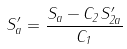<formula> <loc_0><loc_0><loc_500><loc_500>S _ { a } ^ { \prime } = \frac { S _ { a } - C _ { 2 } S ^ { \prime } _ { 2 a } } { C _ { 1 } }</formula> 